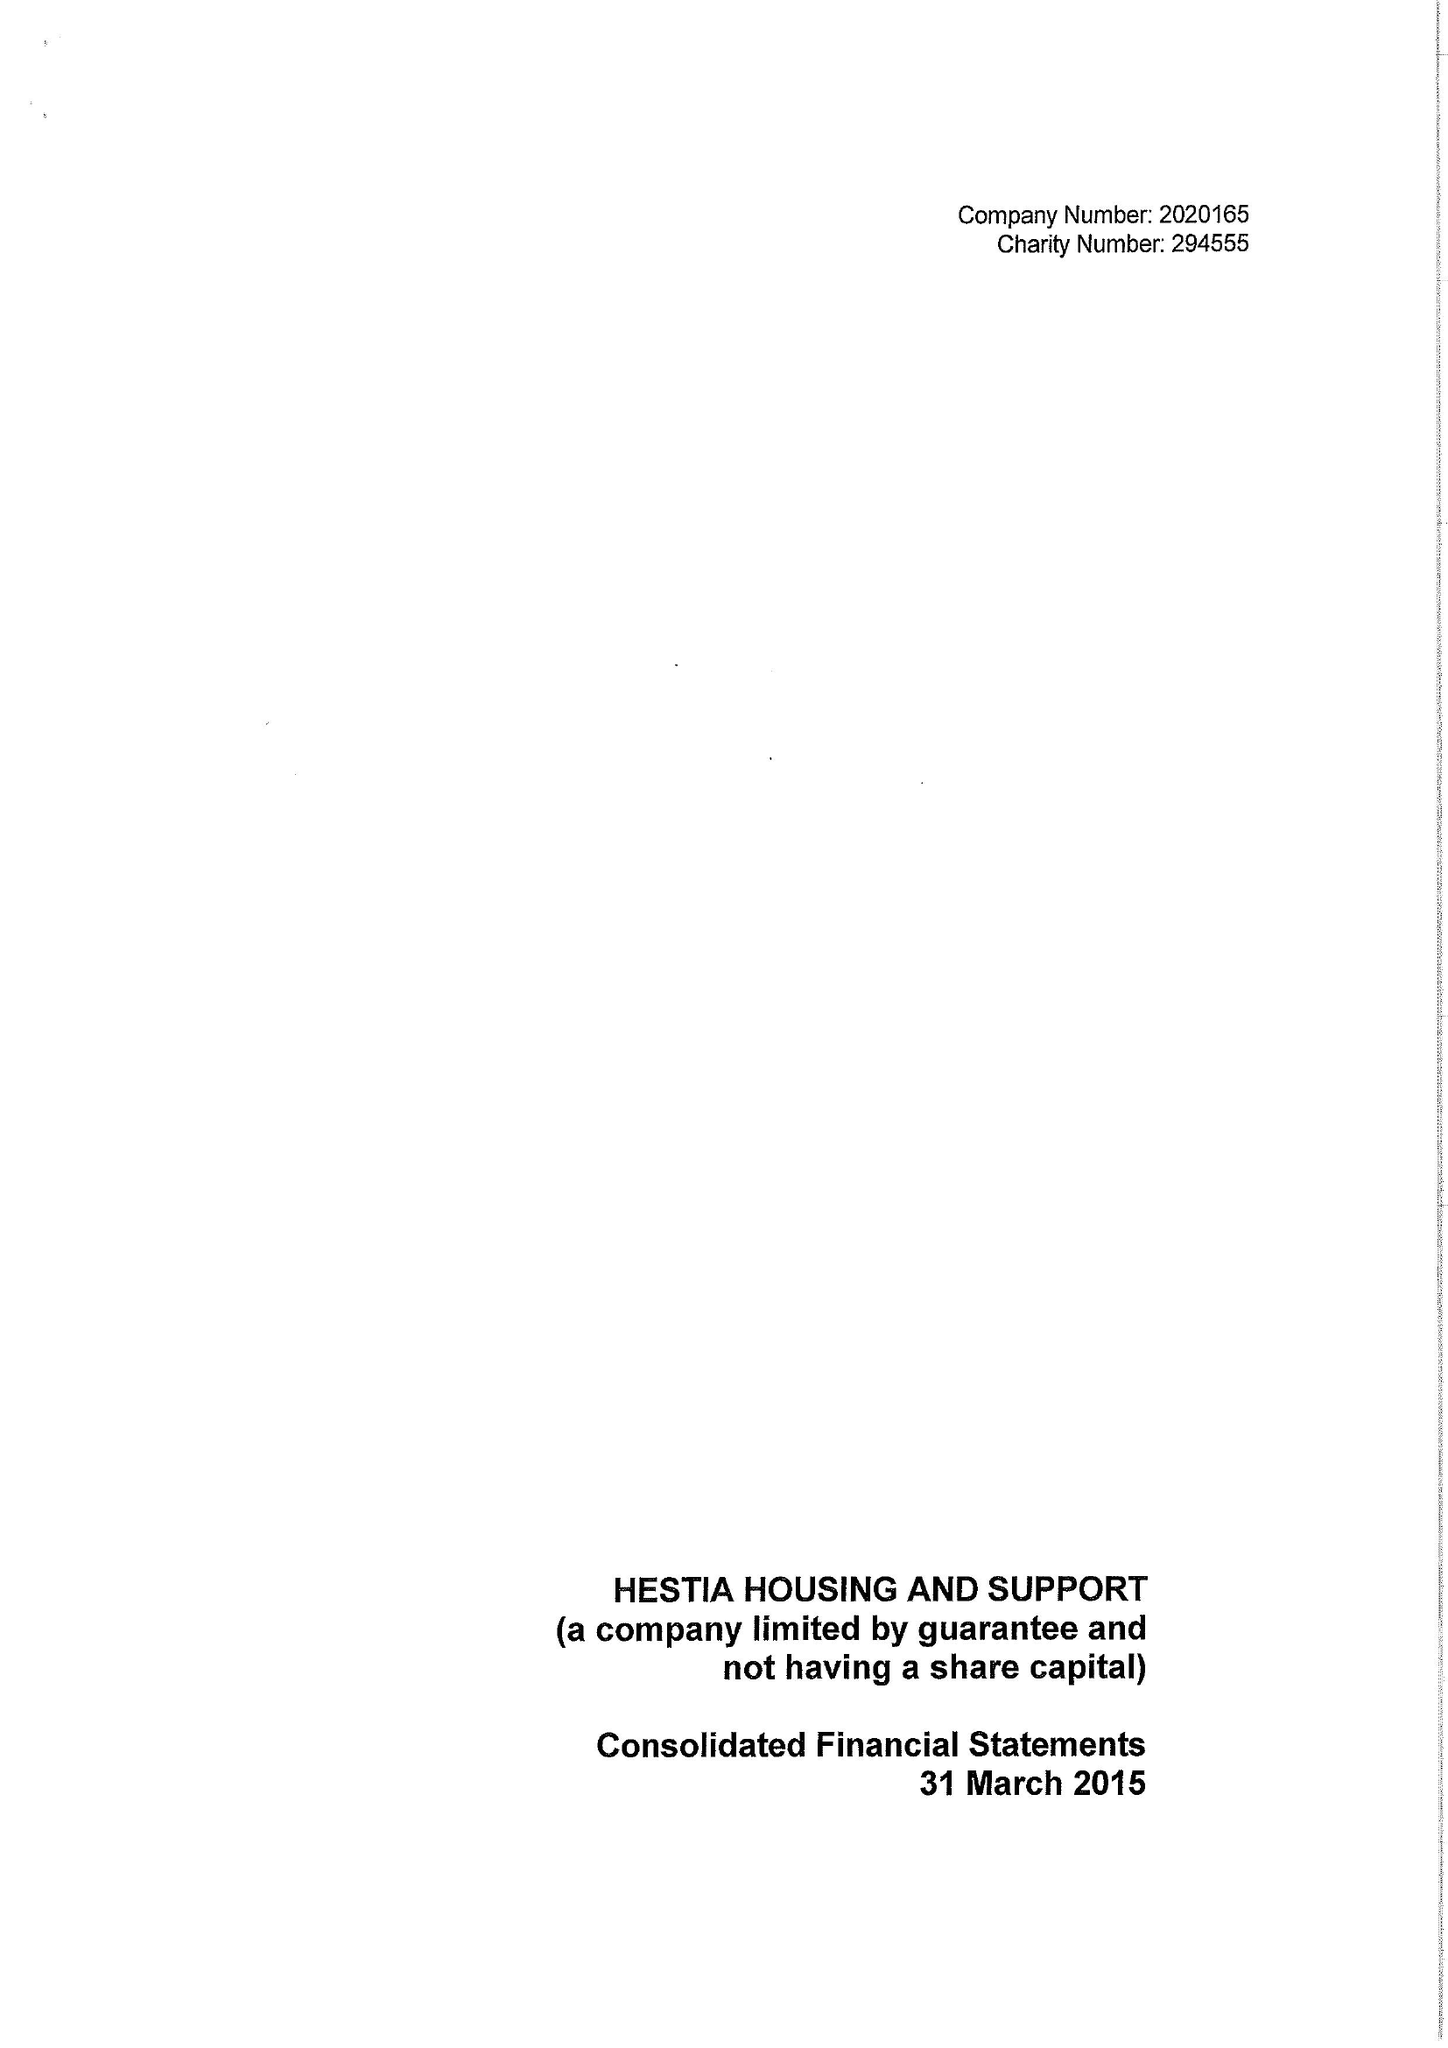What is the value for the income_annually_in_british_pounds?
Answer the question using a single word or phrase. 21565721.00 